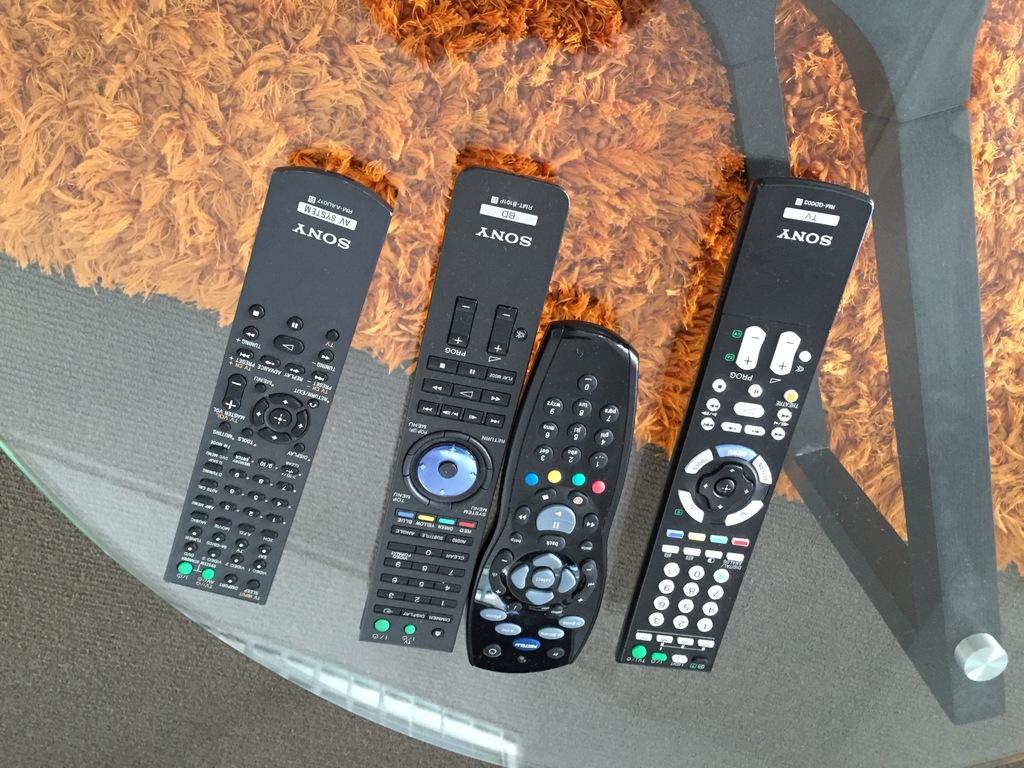What brand are the remotes?
Provide a succinct answer. Sony. 